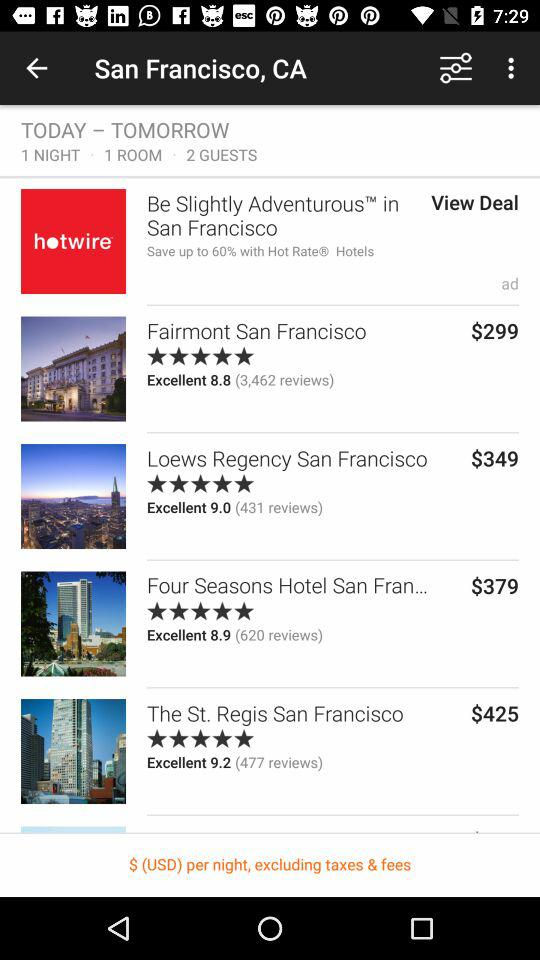Which hotel received a 3 star review?
When the provided information is insufficient, respond with <no answer>. <no answer> 